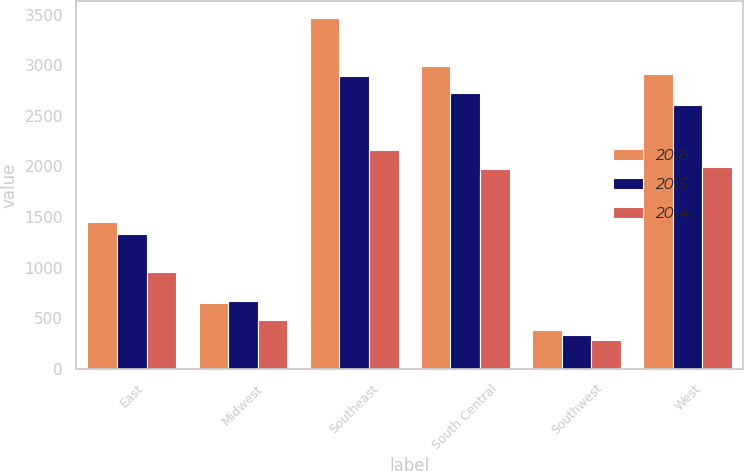Convert chart to OTSL. <chart><loc_0><loc_0><loc_500><loc_500><stacked_bar_chart><ecel><fcel>East<fcel>Midwest<fcel>Southeast<fcel>South Central<fcel>Southwest<fcel>West<nl><fcel>2016<fcel>1446.5<fcel>651.7<fcel>3463.5<fcel>2995.1<fcel>388.1<fcel>2916.9<nl><fcel>2015<fcel>1333.6<fcel>666.1<fcel>2890.6<fcel>2725.2<fcel>336.1<fcel>2607.4<nl><fcel>2014<fcel>954.7<fcel>483.5<fcel>2167<fcel>1971.2<fcel>285.2<fcel>1996.9<nl></chart> 